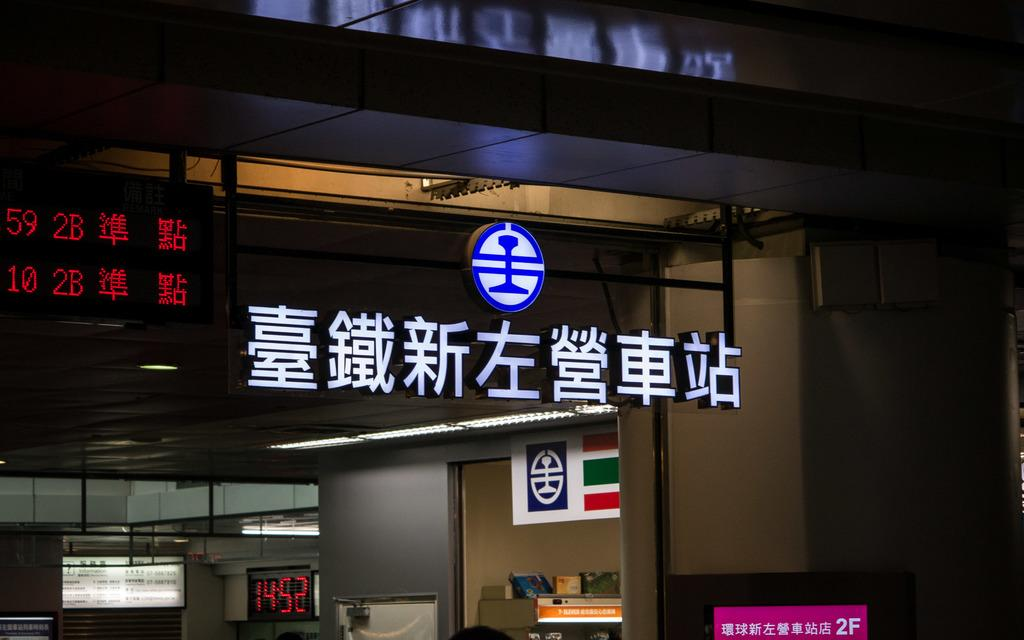What is the main structure visible in the image? There is a building in the image. What is placed in front of the building? There are boards with text and numbers in front of the building. What type of wool is being sold at the building in the image? There is no indication of wool or any type of product being sold in the image; it only shows a building with boards in front of it. 